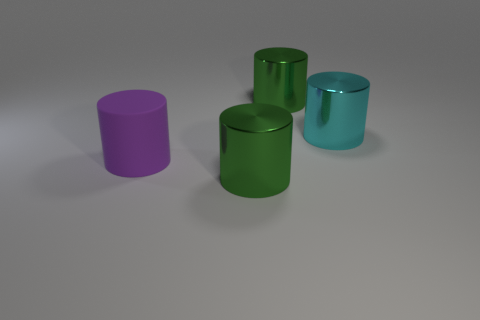Are there fewer things than large metallic things?
Your answer should be compact. No. There is a cylinder on the right side of the green shiny object that is on the right side of the green metallic object that is in front of the rubber object; what color is it?
Make the answer very short. Cyan. Is the cyan object made of the same material as the big purple cylinder?
Offer a terse response. No. There is a purple rubber cylinder; how many purple rubber cylinders are behind it?
Keep it short and to the point. 0. What size is the rubber object that is the same shape as the cyan shiny thing?
Provide a short and direct response. Large. What number of purple objects are either big matte cylinders or large cylinders?
Give a very brief answer. 1. How many large cylinders are on the right side of the green metallic thing in front of the large rubber cylinder?
Offer a very short reply. 2. What number of other objects are there of the same shape as the purple rubber object?
Make the answer very short. 3. How many metallic objects have the same color as the matte cylinder?
Provide a succinct answer. 0. Are there any cyan cylinders that have the same size as the purple rubber cylinder?
Offer a terse response. Yes. 